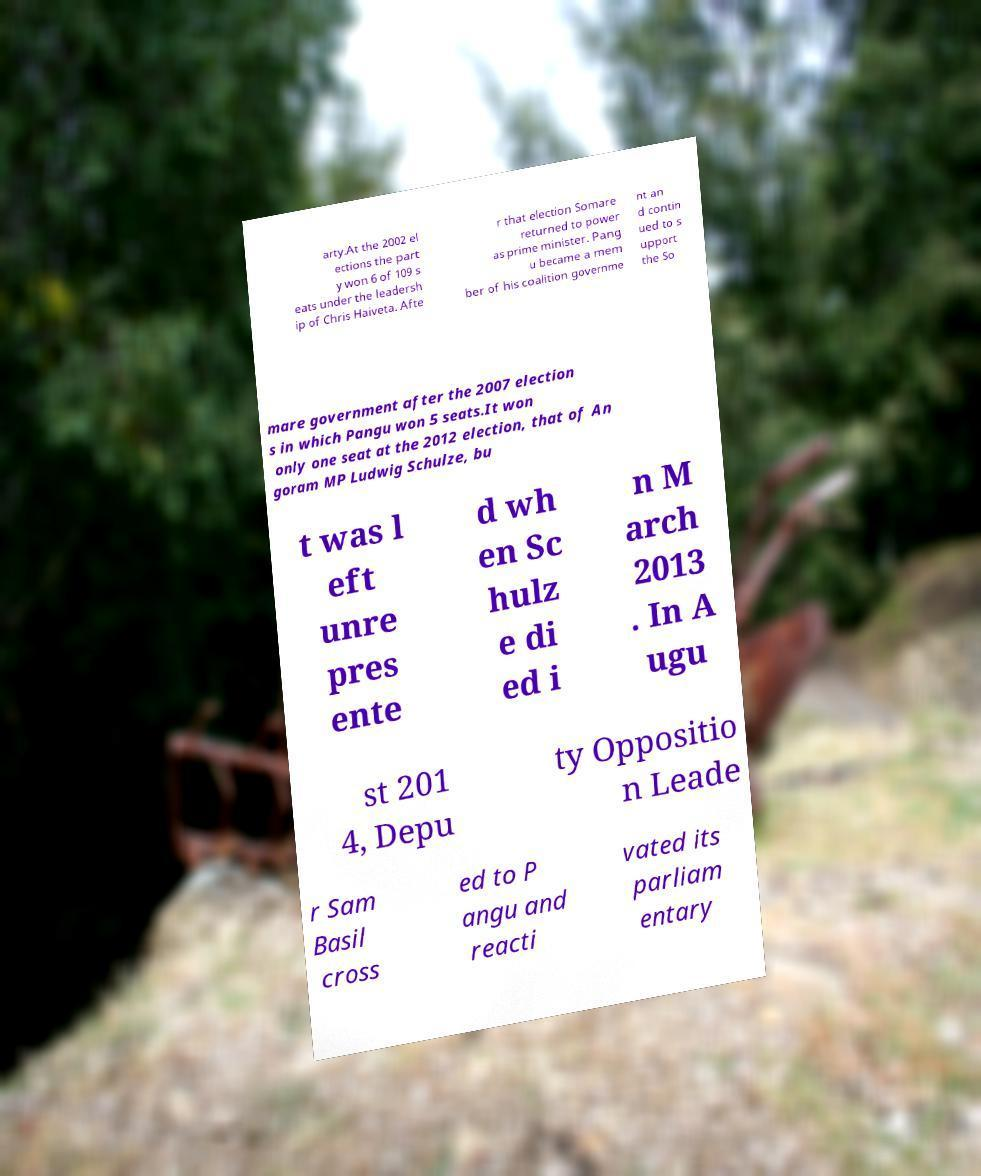Can you accurately transcribe the text from the provided image for me? arty.At the 2002 el ections the part y won 6 of 109 s eats under the leadersh ip of Chris Haiveta. Afte r that election Somare returned to power as prime minister. Pang u became a mem ber of his coalition governme nt an d contin ued to s upport the So mare government after the 2007 election s in which Pangu won 5 seats.It won only one seat at the 2012 election, that of An goram MP Ludwig Schulze, bu t was l eft unre pres ente d wh en Sc hulz e di ed i n M arch 2013 . In A ugu st 201 4, Depu ty Oppositio n Leade r Sam Basil cross ed to P angu and reacti vated its parliam entary 